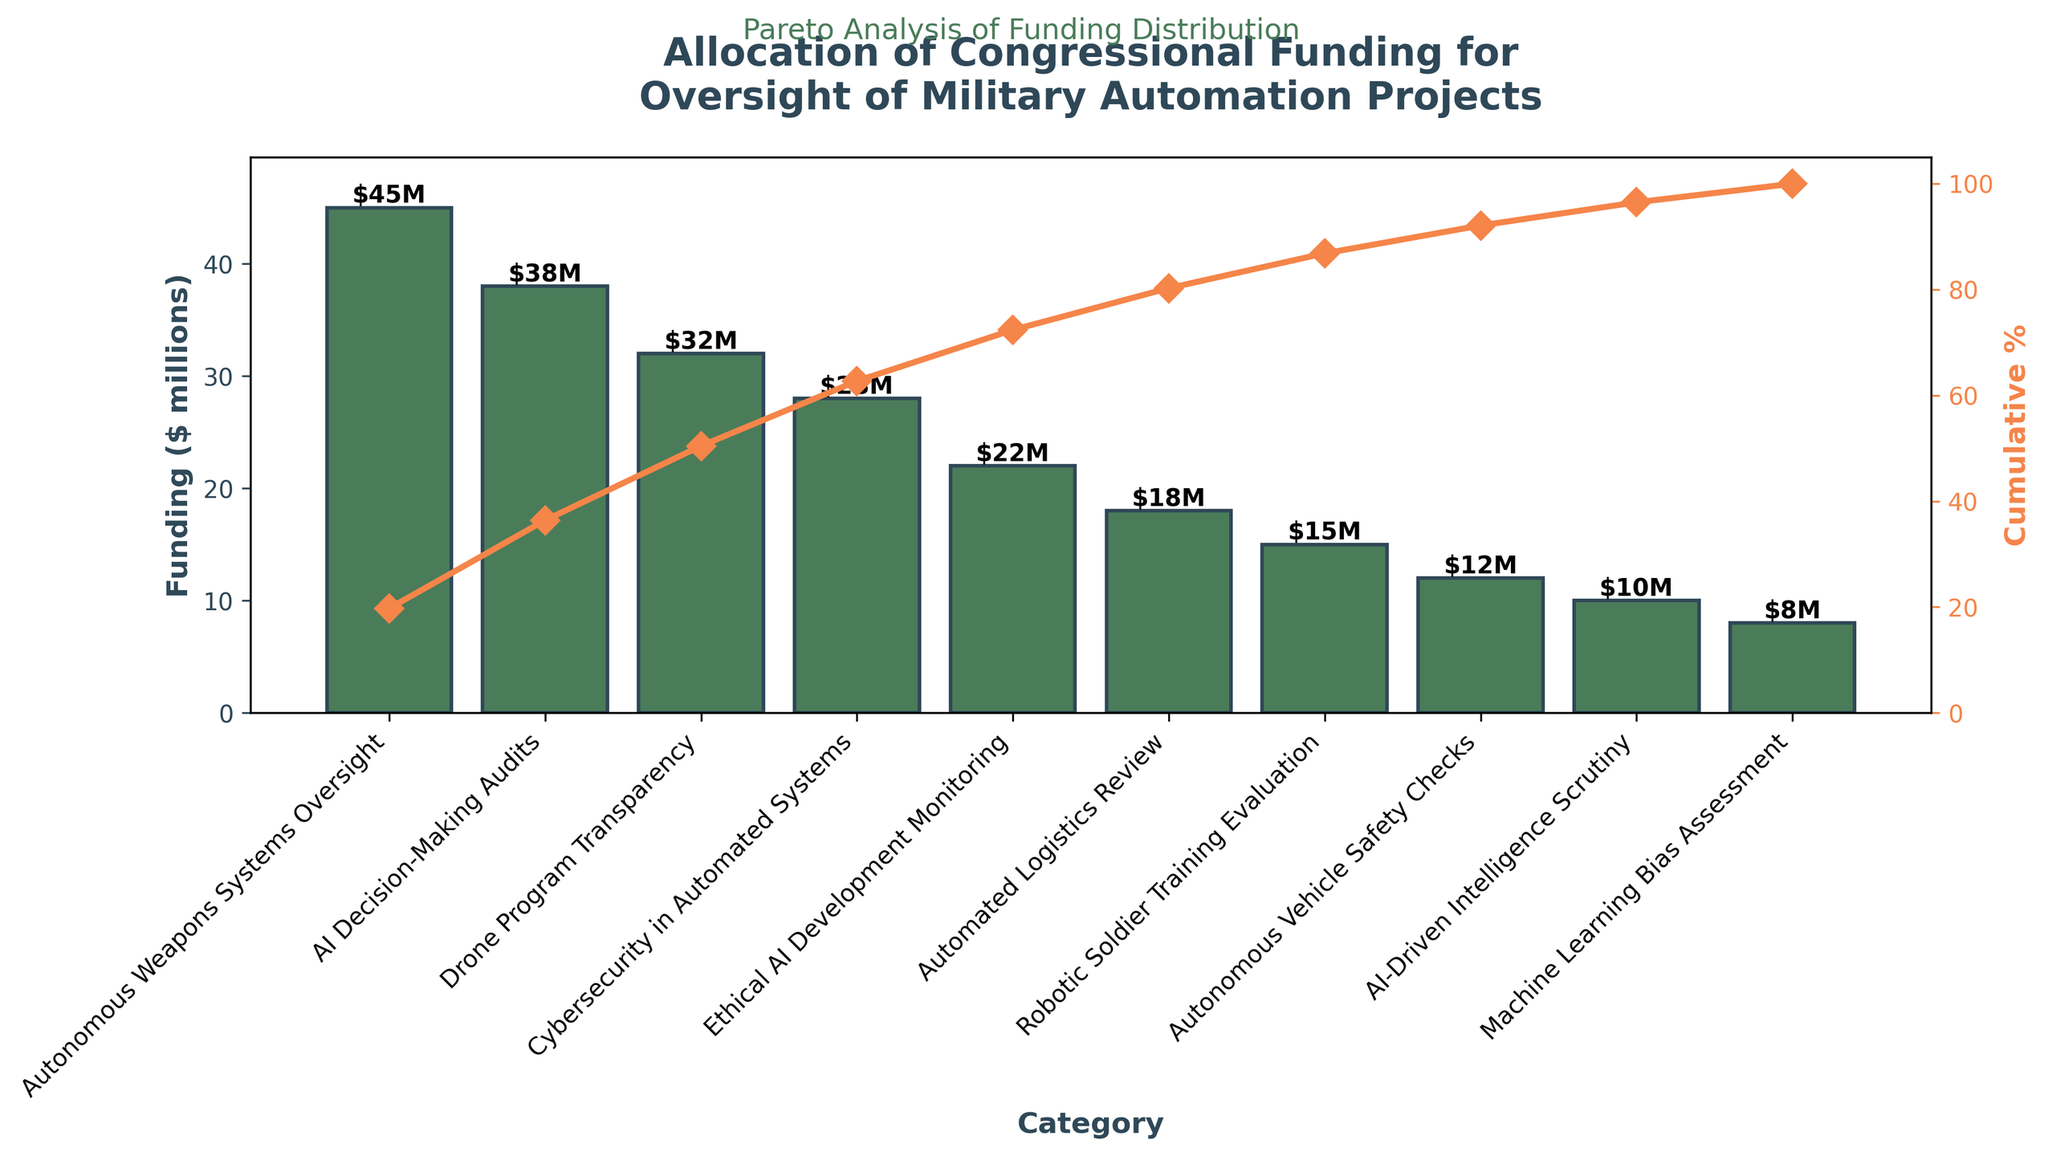what is the funding for "Cybersecurity in Automated Systems"? The bar for "Cybersecurity in Automated Systems" shows the funding amount on the y-axis.
Answer: $28 million How much does the "Autonomous Weapons Systems Oversight" category receive more than the "Autonomous Vehicle Safety Checks" category? The funding for "Autonomous Weapons Systems Oversight" is $45 million, and for "Autonomous Vehicle Safety Checks" it is $12 million. So, $45 million - $12 million = $33 million.
Answer: $33 million Which funding category reaches closest to the 70% cumulative mark? Looking at the cumulative percentage line, the category that comes closest to but does not exceed 70% is "Drone Program Transparency".
Answer: "Drone Program Transparency" How many categories receive more than $20 million in funding? The bars representing more than $20 million are for "Autonomous Weapons Systems Oversight," "AI Decision-Making Audits," "Drone Program Transparency," "Cybersecurity in Automated Systems," and "Ethical AI Development Monitoring." Therefore, there are 5 categories.
Answer: 5 What is the total funding allocated to the top three categories? The top three categories are "Autonomous Weapons Systems Oversight" ($45 million), "AI Decision-Making Audits" ($38 million), and "Drone Program Transparency" ($32 million). Adding them up gives $45 million + $38 million + $32 million = $115 million.
Answer: $115 million Which category is just below "Robotic Soldier Training Evaluation" in terms of cumulative percentage? Looking at the cumulative percentage line, "Autonomous Vehicle Safety Checks" follows "Robotic Soldier Training Evaluation."
Answer: "Autonomous Vehicle Safety Checks" What is the cumulative percentage after the first two categories? "Autonomous Weapons Systems Oversight" has a cumulative percentage of approximately 24.5%, and "AI Decision-Making Audits" pushes it to around 24.5% + 20.7% = 45.2%.
Answer: 45.2% Is the "Machine Learning Bias Assessment" category above or below 90% cumulative percentage? The "Machine Learning Bias Assessment" has a cumulative percentage that looks to be just under 90% on the cumulative percentage line.
Answer: Below How much funding does the smallest category receive, and what is it? The smallest category is "Machine Learning Bias Assessment" with funding of $8 million.
Answer: $8 million How many categories need to be included to reach over 50% cumulative funding? "Autonomous Weapons Systems Oversight" and "AI Decision-Making Audits" together cover around 45.2%. Adding "Drone Program Transparency" brings the total to just above 70%. So, 3 categories are needed.
Answer: 3 